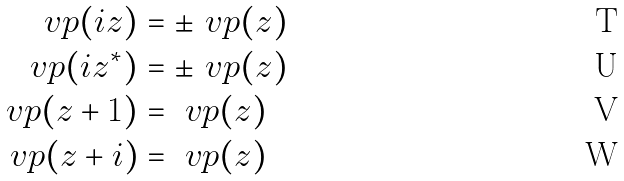Convert formula to latex. <formula><loc_0><loc_0><loc_500><loc_500>\ v p ( i z ) & = \pm \ v p ( z ) \\ \ v p ( i z ^ { * } ) & = \pm \ v p ( z ) \\ \ v p ( z + 1 ) & = \ v p ( z ) \\ \ v p ( z + i ) & = \ v p ( z )</formula> 